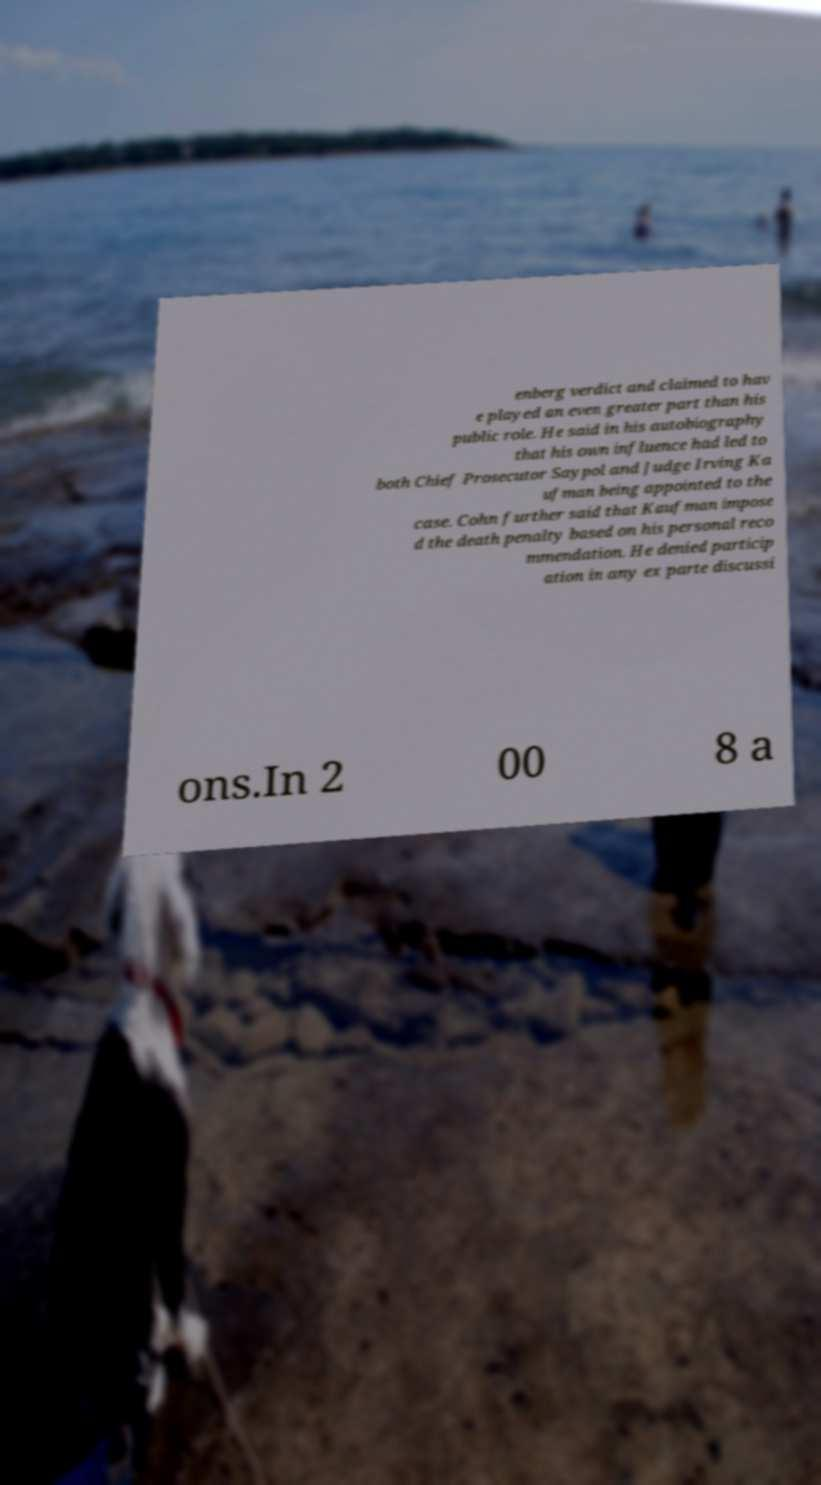I need the written content from this picture converted into text. Can you do that? enberg verdict and claimed to hav e played an even greater part than his public role. He said in his autobiography that his own influence had led to both Chief Prosecutor Saypol and Judge Irving Ka ufman being appointed to the case. Cohn further said that Kaufman impose d the death penalty based on his personal reco mmendation. He denied particip ation in any ex parte discussi ons.In 2 00 8 a 